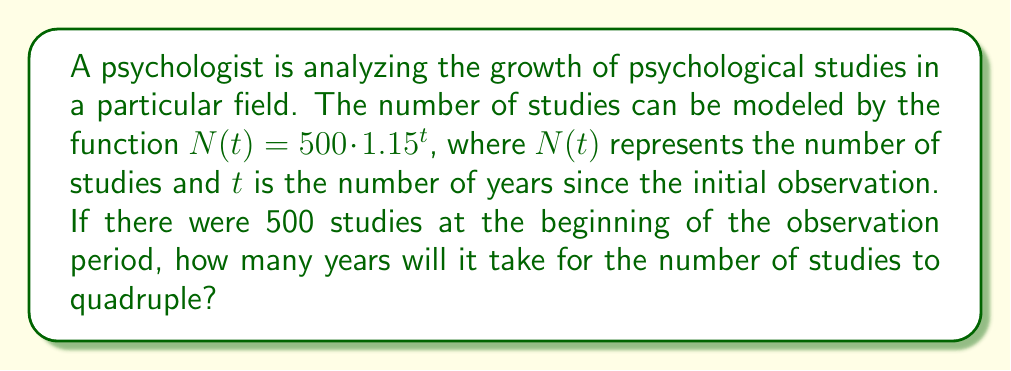Solve this math problem. Let's approach this step-by-step:

1) We start with the given function: $N(t) = 500 \cdot 1.15^t$

2) We want to find when the number of studies quadruples. This means we're looking for when $N(t) = 4 \cdot 500 = 2000$

3) Let's set up the equation:
   $2000 = 500 \cdot 1.15^t$

4) Divide both sides by 500:
   $4 = 1.15^t$

5) Now, we need to solve for $t$. We can do this using logarithms:
   $\log_{\,1.15} 4 = t$

6) Change of base formula:
   $t = \frac{\log 4}{\log 1.15}$

7) Using a calculator:
   $t \approx 9.66$ years

8) Since we're dealing with whole years, we round up to 10 years.

This aligns with our interdisciplinary approach, combining psychology research trends with mathematical modeling.
Answer: 10 years 